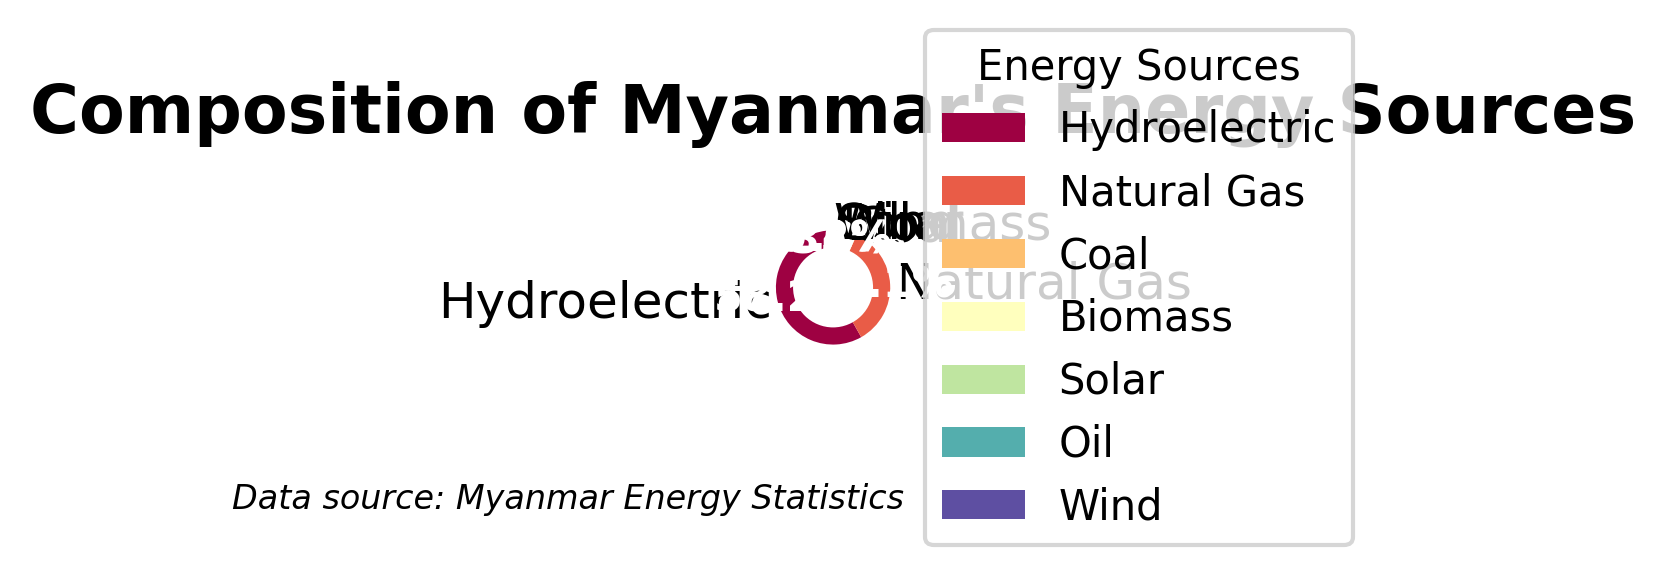Which energy source has the highest percentage? Identify the segment representing the highest percentage and refer to its label. Hydroelectric has the largest segment.
Answer: Hydroelectric Which energy sources have percentages less than 2%? Locate the segments that are less than 2% and refer to their labels. Biomass, Solar, Oil, and Wind have segments less than 2%.
Answer: Biomass, Solar, Oil, Wind What is the total percentage of renewable energy sources (Hydroelectric, Biomass, Solar, Wind) in Myanmar? Sum the percentages of the renewable sources: Hydroelectric (58.2), Biomass (1.8), Solar (0.6), and Wind (0.2). 58.2 + 1.8 + 0.6 + 0.2 = 60.8%
Answer: 60.8% How much more energy does Hydroelectric produce compared to Natural Gas? Subtract the percentage of Natural Gas from Hydroelectric: 58.2% - 35.1% = 23.1%.
Answer: 23.1% Which energy source is represented by the smallest segment? Identify the segment with the smallest percentage and refer to its label. Wind has the smallest segment.
Answer: Wind How many energy sources have a percentage between 0% and 5%? Count the segments that have percentages between 0% and 5%: Coal (3.7), Biomass (1.8), Solar (0.6), Oil (0.4), Wind (0.2).
Answer: 5 What is the combined percentage of the sources represented by warm colors (red, orange, yellow)? Identify the sources represented by warm colors: Solar and Wind, then sum their percentages: 0.6% + 0.2% = 0.8%.
Answer: 0.8% Which energy source is placed directly to the left of Natural Gas in the pie chart? Examine the position of segments in the pie chart. Coal is directly to the left of Natural Gas.
Answer: Coal What percentage does the 'Other' category (comprising the energy sources except Hydroelectric and Natural Gas) represent? Sum the percentages of all sources except Hydroelectric and Natural Gas: Coal (3.7), Biomass (1.8), Solar (0.6), Oil (0.4), Wind (0.2). Adding these together: 3.7 + 1.8 + 0.6 + 0.4 + 0.2 = 6.7%.
Answer: 6.7% What is the percentage difference between the third-largest and the smallest energy source? Identify the third-largest source (Coal at 3.7%) and the smallest (Wind at 0.2%), then subtract: 3.7% - 0.2% = 3.5%.
Answer: 3.5% 